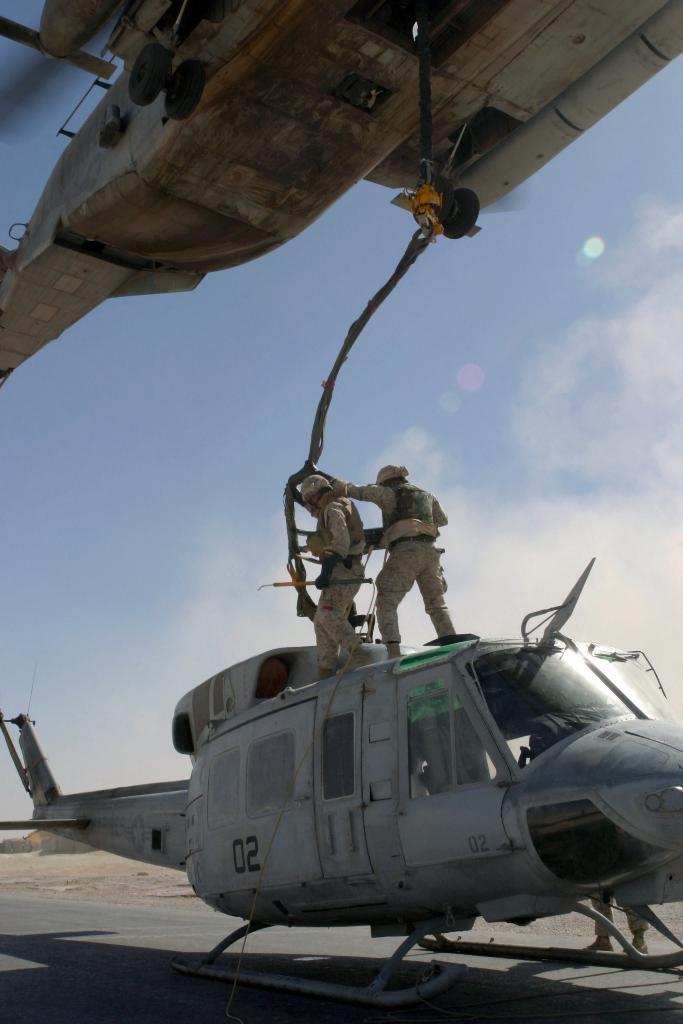<image>
Give a short and clear explanation of the subsequent image. A helicopter displaying the number 02 on the side 